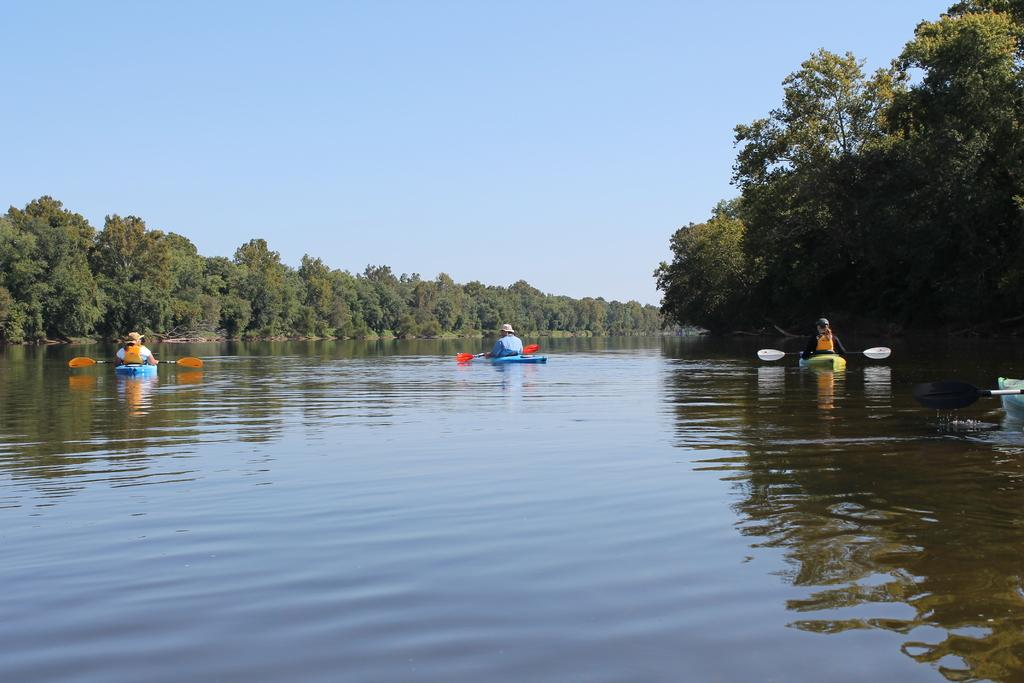What is the main subject of the image? The main subject of the image is a boat. Where is the boat located? The boat is on the water. What are the people on the boat doing? The people are sitting on the boat and holding paddles. What can be seen in the background of the image? There are trees and the sky visible in the image. Can you see the moon in the image? No, the moon is not visible in the image; only the sky and trees are present in the background. Are there any hens on the boat? No, there are no hens present in the image; the people on the boat are holding paddles. 